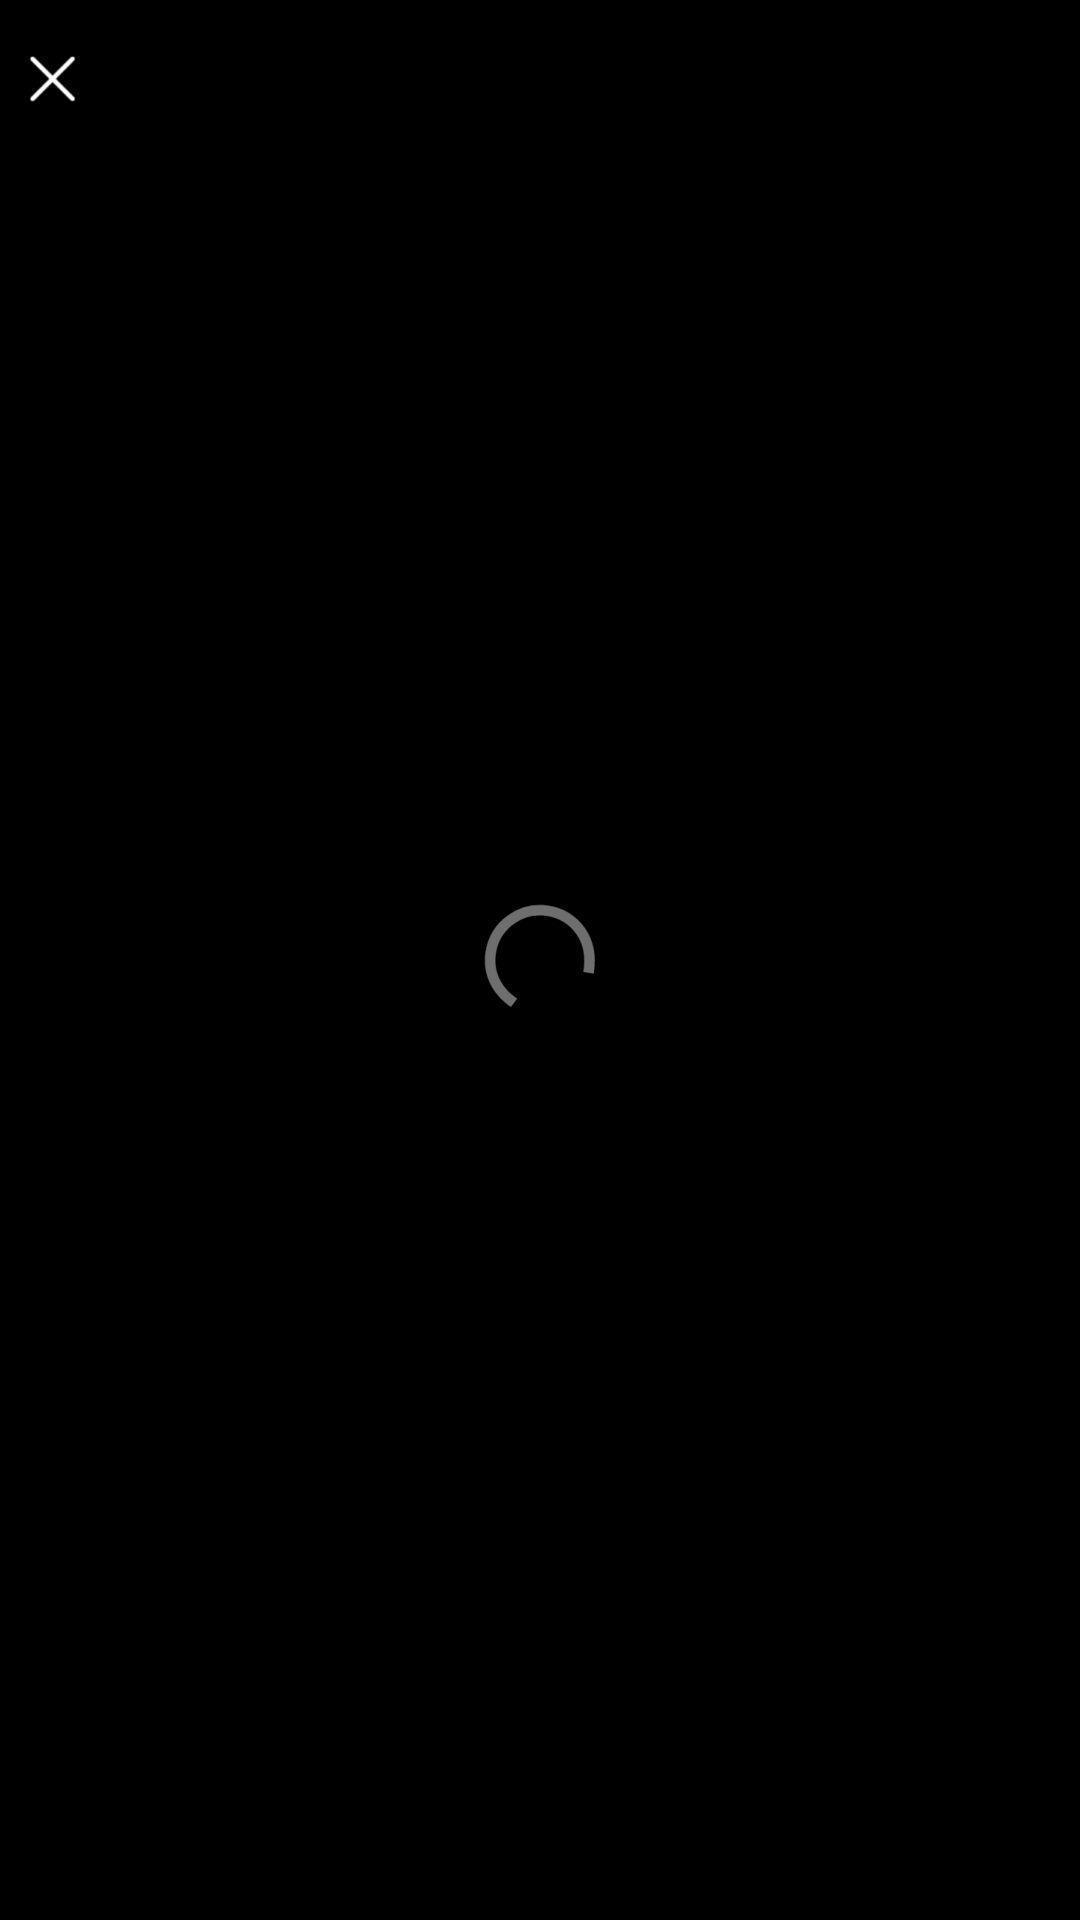Give me a narrative description of this picture. Page displaying the symbol of loading in a news app. 